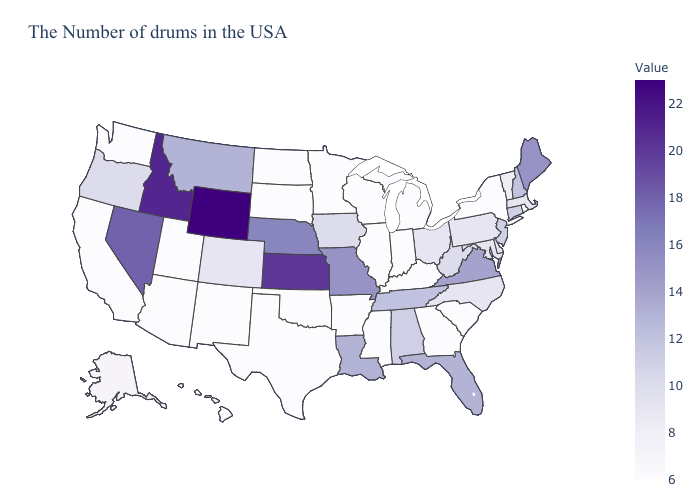Does the map have missing data?
Keep it brief. No. Which states have the highest value in the USA?
Short answer required. Wyoming. Which states hav the highest value in the West?
Give a very brief answer. Wyoming. Does South Carolina have a lower value than Iowa?
Be succinct. Yes. 